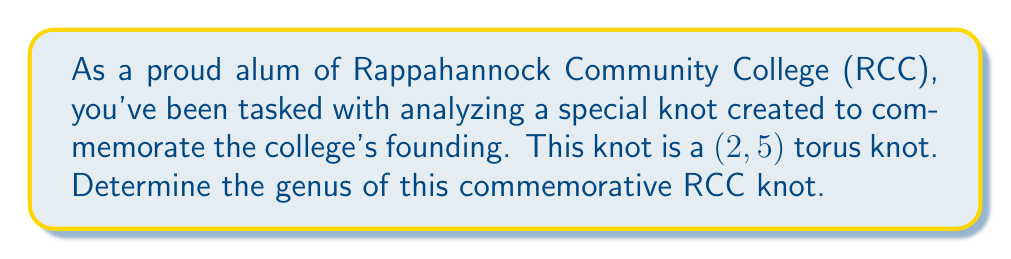Help me with this question. Let's approach this step-by-step:

1) For a $(p,q)$ torus knot, where $p$ and $q$ are coprime integers, the genus $g$ is given by the formula:

   $$g = \frac{(p-1)(q-1)}{2}$$

2) In this case, we have a $(2,5)$ torus knot, so $p=2$ and $q=5$.

3) Let's substitute these values into our formula:

   $$g = \frac{(2-1)(5-1)}{2}$$

4) Simplify:
   $$g = \frac{(1)(4)}{2}$$

5) Calculate:
   $$g = \frac{4}{2} = 2$$

Therefore, the genus of the $(2,5)$ torus knot commemorating RCC is 2.
Answer: $2$ 